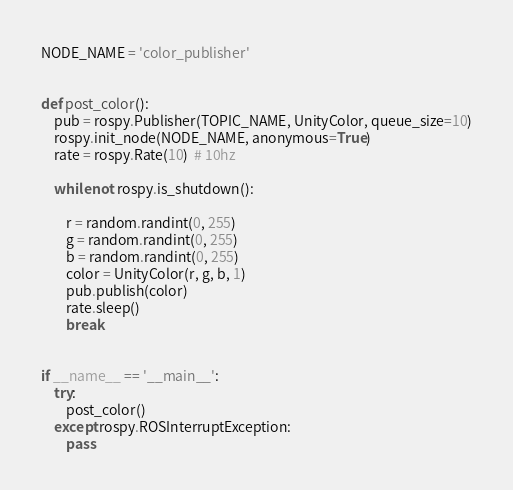Convert code to text. <code><loc_0><loc_0><loc_500><loc_500><_Python_>NODE_NAME = 'color_publisher'


def post_color():
    pub = rospy.Publisher(TOPIC_NAME, UnityColor, queue_size=10)
    rospy.init_node(NODE_NAME, anonymous=True)
    rate = rospy.Rate(10)  # 10hz

    while not rospy.is_shutdown():

        r = random.randint(0, 255)
        g = random.randint(0, 255)
        b = random.randint(0, 255)
        color = UnityColor(r, g, b, 1)
        pub.publish(color)
        rate.sleep()
        break


if __name__ == '__main__':
    try:
        post_color()
    except rospy.ROSInterruptException:
        pass
</code> 